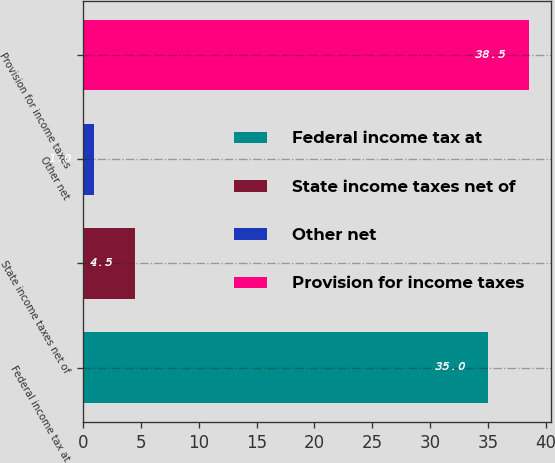Convert chart. <chart><loc_0><loc_0><loc_500><loc_500><bar_chart><fcel>Federal income tax at<fcel>State income taxes net of<fcel>Other net<fcel>Provision for income taxes<nl><fcel>35<fcel>4.5<fcel>1<fcel>38.5<nl></chart> 